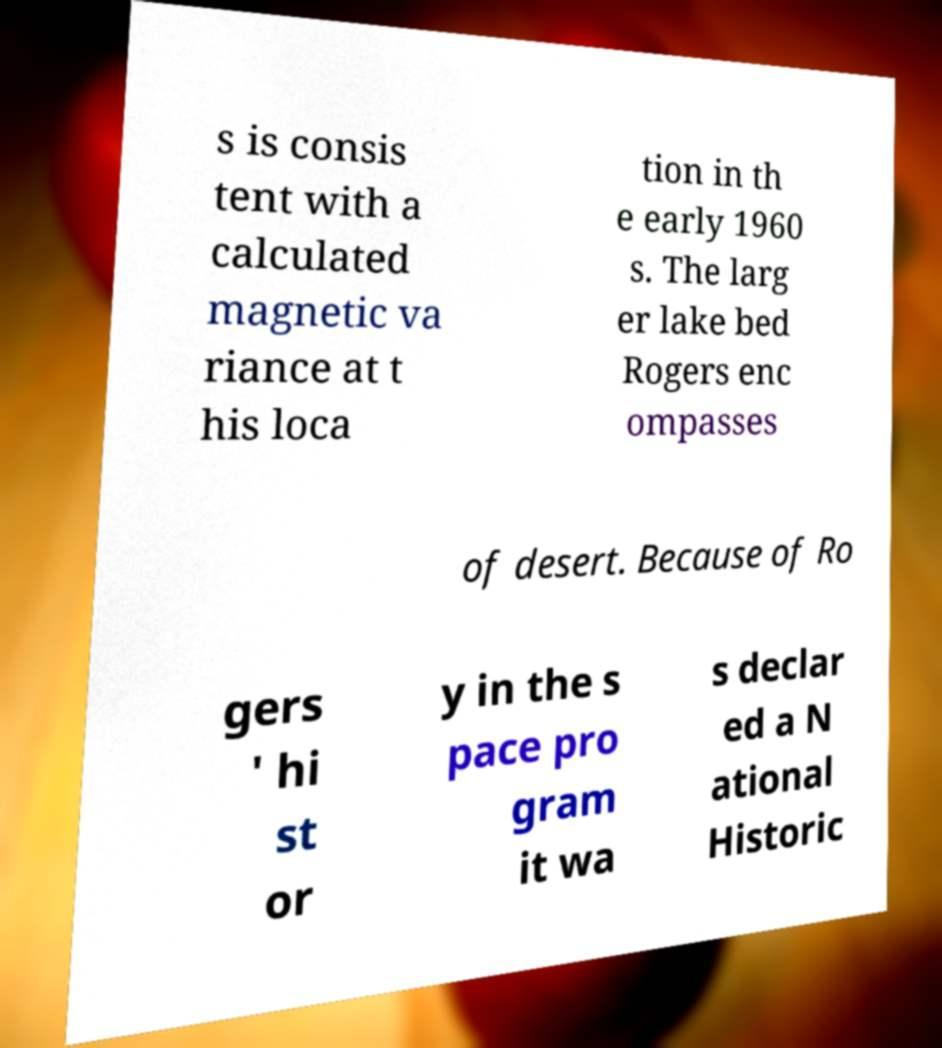Please identify and transcribe the text found in this image. s is consis tent with a calculated magnetic va riance at t his loca tion in th e early 1960 s. The larg er lake bed Rogers enc ompasses of desert. Because of Ro gers ' hi st or y in the s pace pro gram it wa s declar ed a N ational Historic 